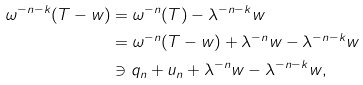Convert formula to latex. <formula><loc_0><loc_0><loc_500><loc_500>\omega ^ { - n - k } ( T - w ) & = \omega ^ { - n } ( T ) - \lambda ^ { - n - k } w \\ & = \omega ^ { - n } ( T - w ) + \lambda ^ { - n } w - \lambda ^ { - n - k } w \\ & \ni q _ { n } + u _ { n } + \lambda ^ { - n } w - \lambda ^ { - n - k } w ,</formula> 